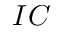<formula> <loc_0><loc_0><loc_500><loc_500>I C</formula> 